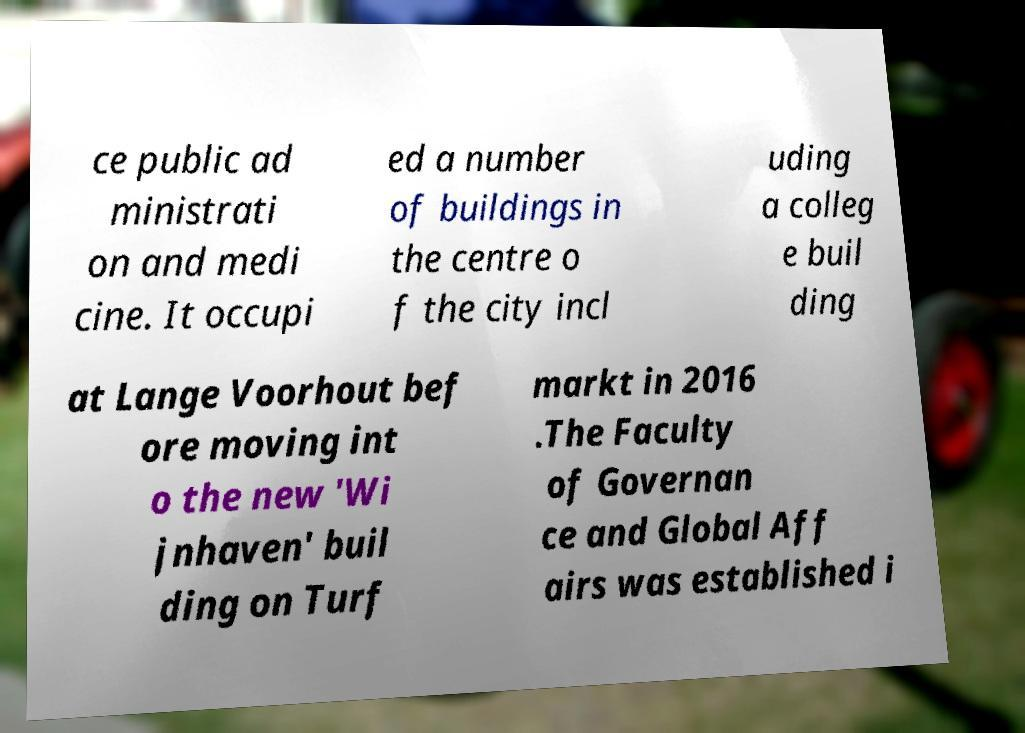Can you accurately transcribe the text from the provided image for me? ce public ad ministrati on and medi cine. It occupi ed a number of buildings in the centre o f the city incl uding a colleg e buil ding at Lange Voorhout bef ore moving int o the new 'Wi jnhaven' buil ding on Turf markt in 2016 .The Faculty of Governan ce and Global Aff airs was established i 